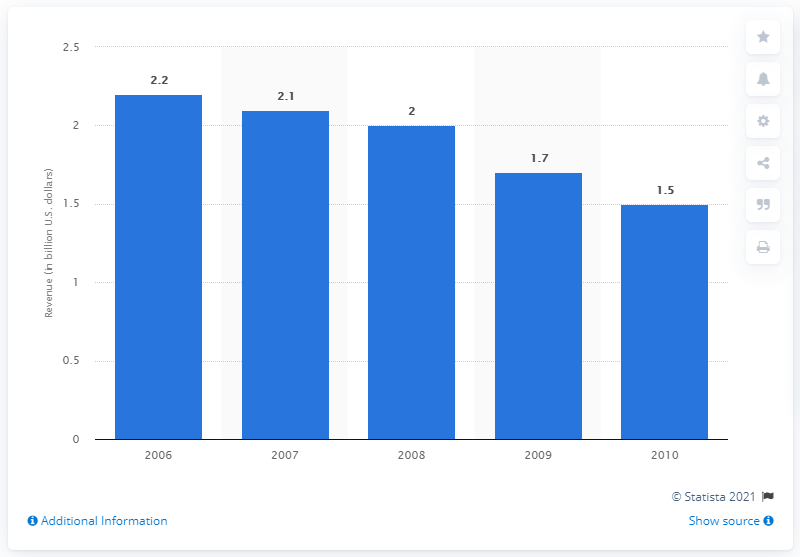Indicate a few pertinent items in this graphic. In the year 2006, the amount of money generated by coin-operated pool tables in the United States was approximately 2.2 billion dollars. 